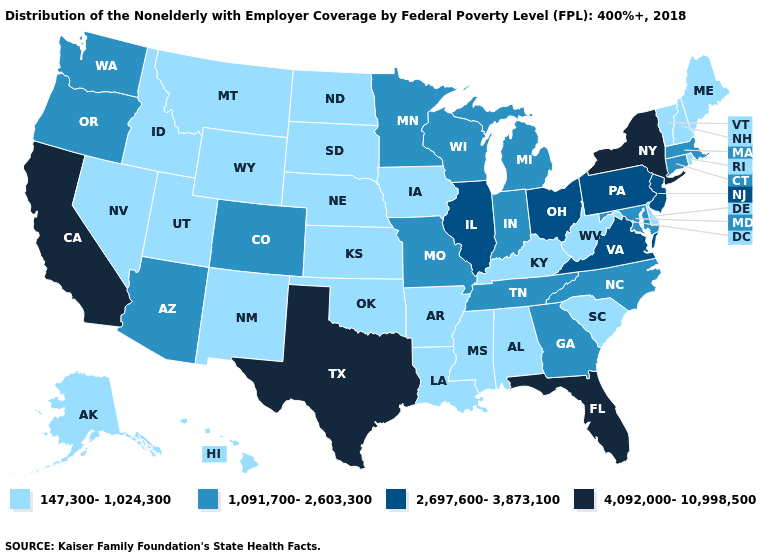Name the states that have a value in the range 147,300-1,024,300?
Keep it brief. Alabama, Alaska, Arkansas, Delaware, Hawaii, Idaho, Iowa, Kansas, Kentucky, Louisiana, Maine, Mississippi, Montana, Nebraska, Nevada, New Hampshire, New Mexico, North Dakota, Oklahoma, Rhode Island, South Carolina, South Dakota, Utah, Vermont, West Virginia, Wyoming. Does the map have missing data?
Quick response, please. No. Among the states that border Wyoming , which have the lowest value?
Give a very brief answer. Idaho, Montana, Nebraska, South Dakota, Utah. Does the first symbol in the legend represent the smallest category?
Give a very brief answer. Yes. Name the states that have a value in the range 4,092,000-10,998,500?
Be succinct. California, Florida, New York, Texas. Name the states that have a value in the range 2,697,600-3,873,100?
Answer briefly. Illinois, New Jersey, Ohio, Pennsylvania, Virginia. What is the highest value in states that border Vermont?
Be succinct. 4,092,000-10,998,500. Does Texas have the highest value in the USA?
Quick response, please. Yes. What is the value of Mississippi?
Write a very short answer. 147,300-1,024,300. Name the states that have a value in the range 1,091,700-2,603,300?
Give a very brief answer. Arizona, Colorado, Connecticut, Georgia, Indiana, Maryland, Massachusetts, Michigan, Minnesota, Missouri, North Carolina, Oregon, Tennessee, Washington, Wisconsin. What is the lowest value in states that border Nevada?
Answer briefly. 147,300-1,024,300. Does Georgia have a lower value than Texas?
Answer briefly. Yes. What is the value of Virginia?
Quick response, please. 2,697,600-3,873,100. What is the value of Iowa?
Concise answer only. 147,300-1,024,300. What is the lowest value in the South?
Answer briefly. 147,300-1,024,300. 